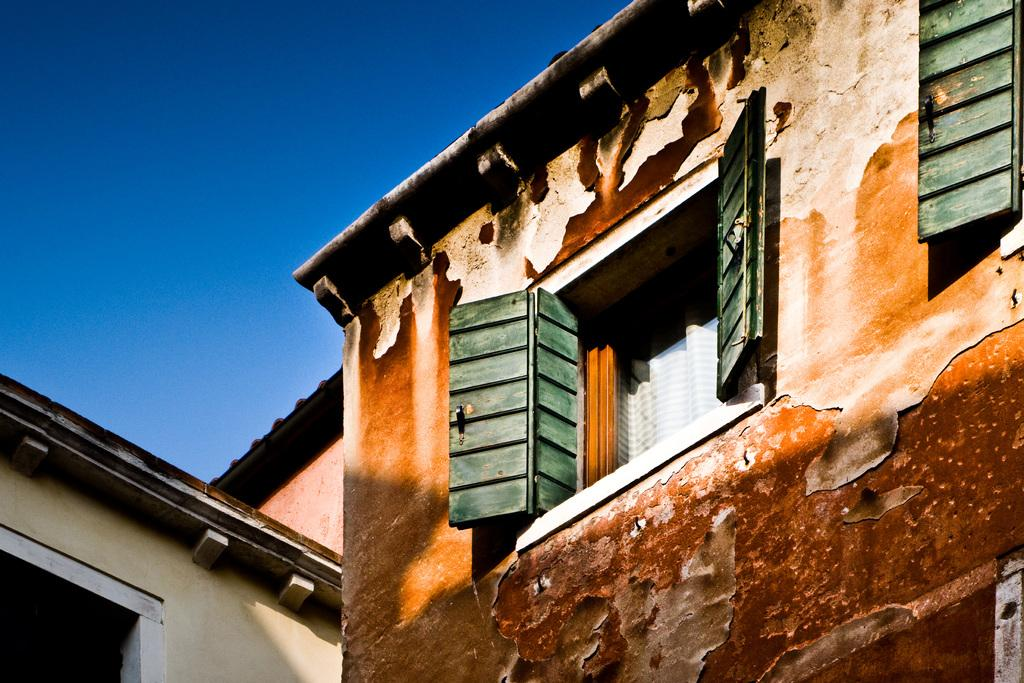What type of structure is depicted in the image? There is a picture of an old building in the image. Can you describe any specific features of the building? The image shows an open window. Where is the map hidden in the image? There is no map present in the image. What type of seed is growing near the building in the image? There is no seed or plant visible in the image. 